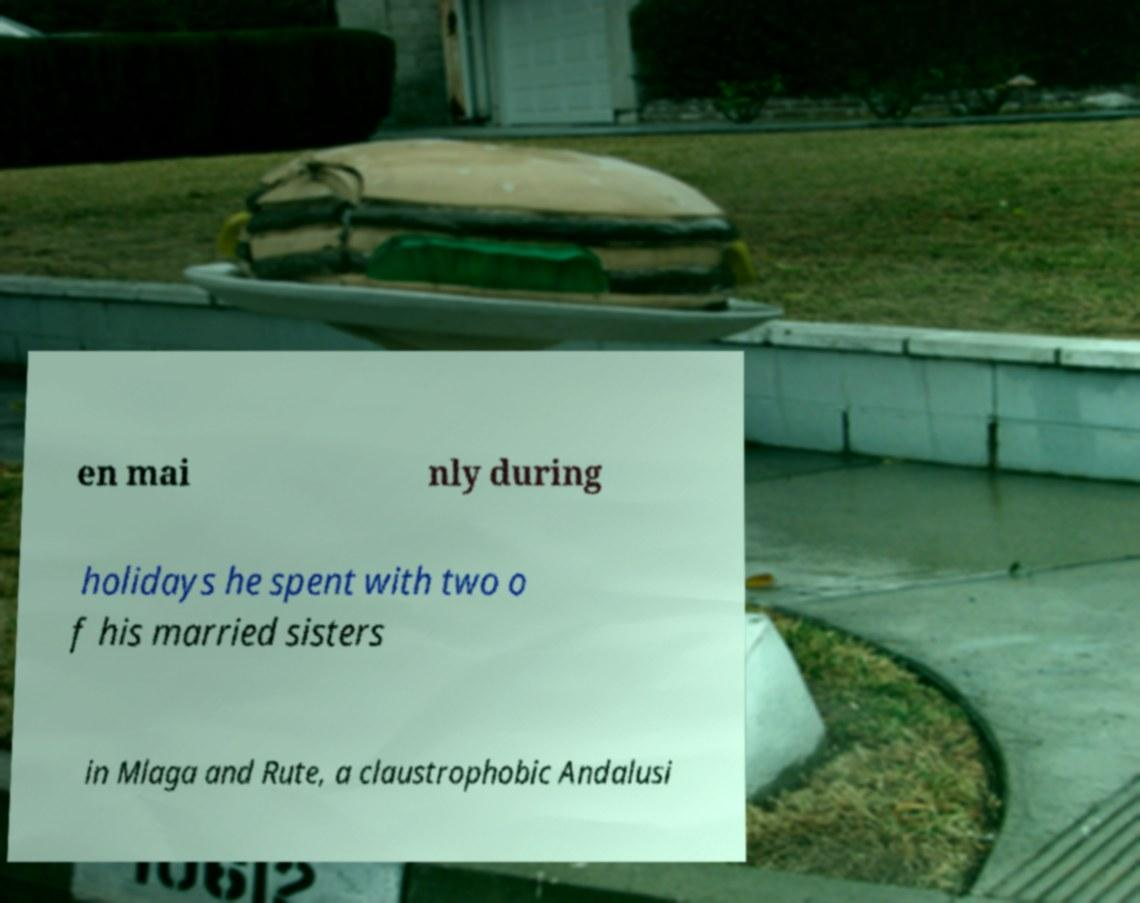Could you extract and type out the text from this image? en mai nly during holidays he spent with two o f his married sisters in Mlaga and Rute, a claustrophobic Andalusi 